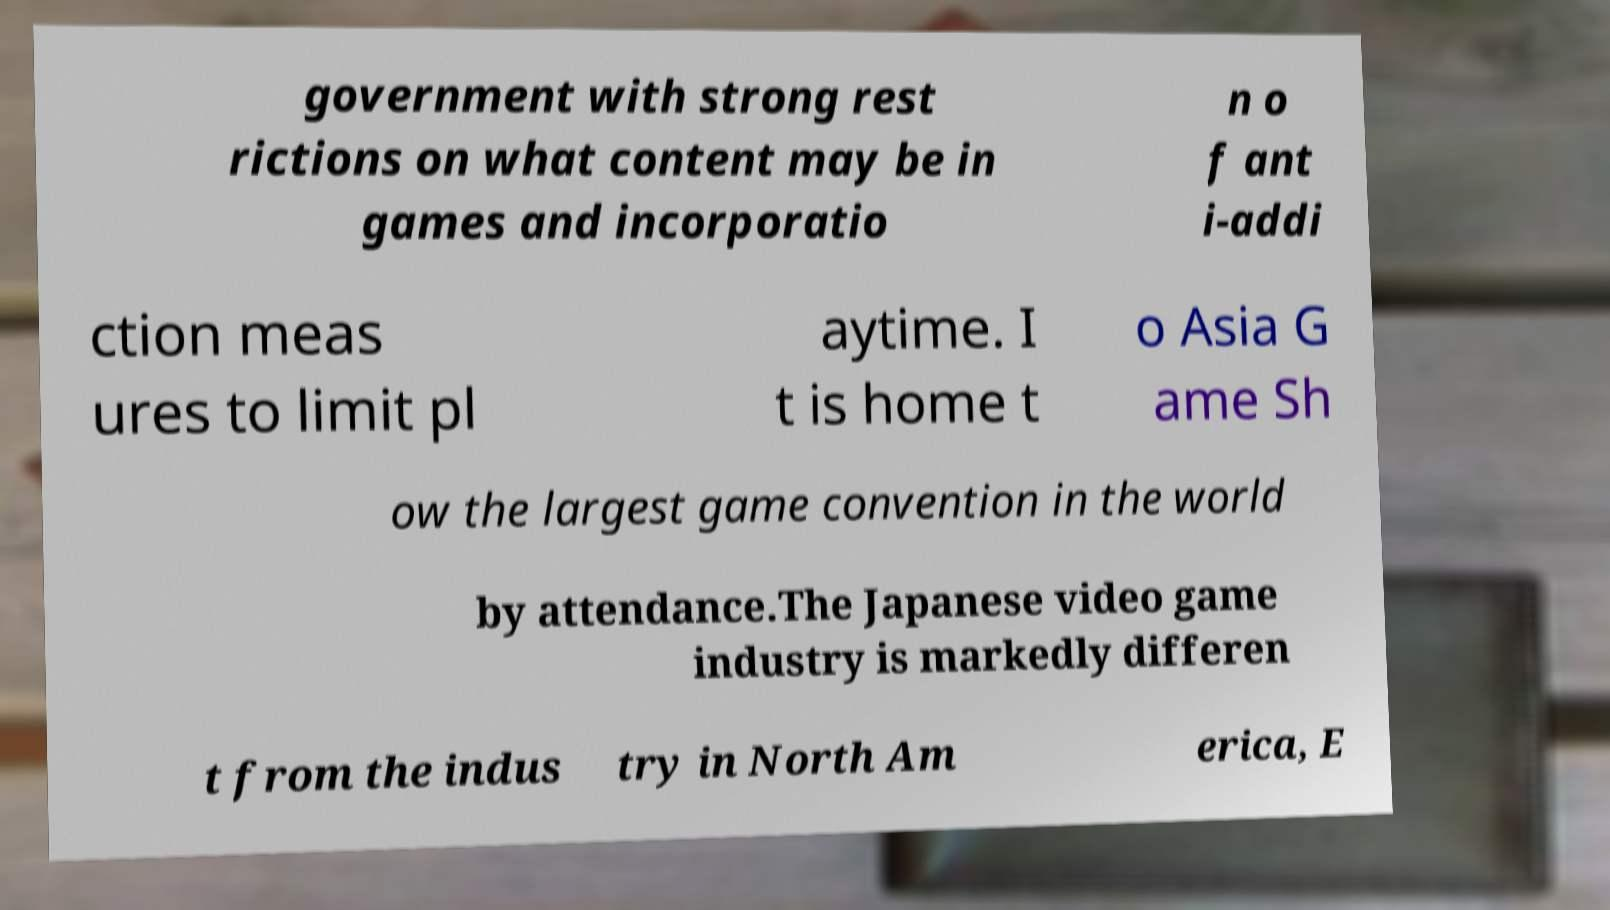Could you extract and type out the text from this image? government with strong rest rictions on what content may be in games and incorporatio n o f ant i-addi ction meas ures to limit pl aytime. I t is home t o Asia G ame Sh ow the largest game convention in the world by attendance.The Japanese video game industry is markedly differen t from the indus try in North Am erica, E 